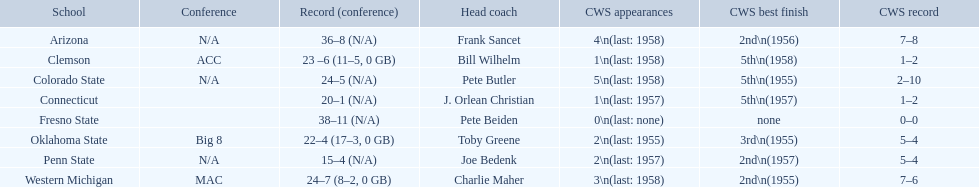Which teams are part of the conference? Arizona, Clemson, Colorado State, Connecticut, Fresno State, Oklahoma State, Penn State, Western Michigan. Among them, which ones have over 16 victories? Arizona, Clemson, Colorado State, Connecticut, Fresno State, Oklahoma State, Western Michigan. Which ones have fewer than 16 wins? Penn State. 